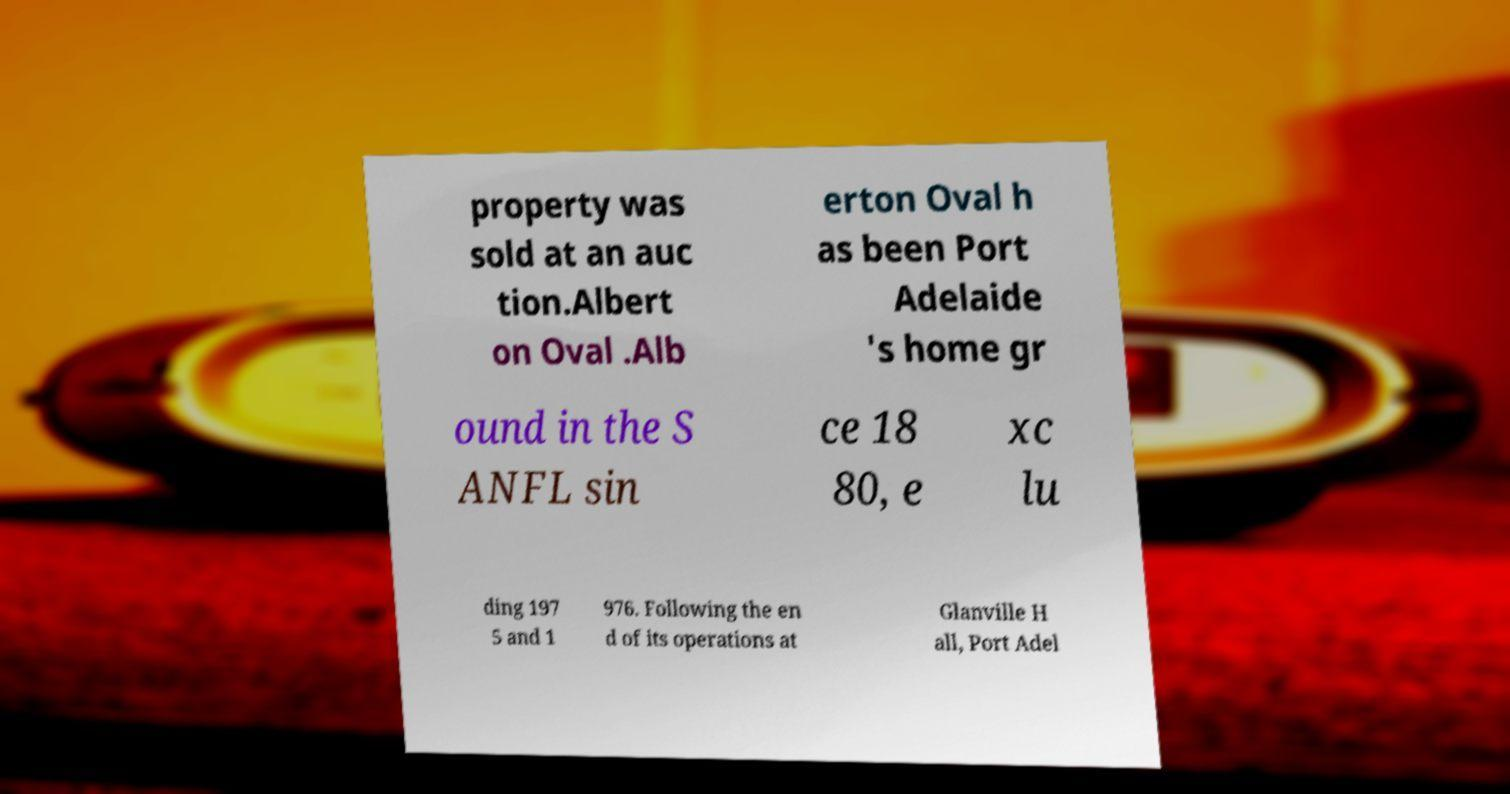Can you accurately transcribe the text from the provided image for me? property was sold at an auc tion.Albert on Oval .Alb erton Oval h as been Port Adelaide 's home gr ound in the S ANFL sin ce 18 80, e xc lu ding 197 5 and 1 976. Following the en d of its operations at Glanville H all, Port Adel 